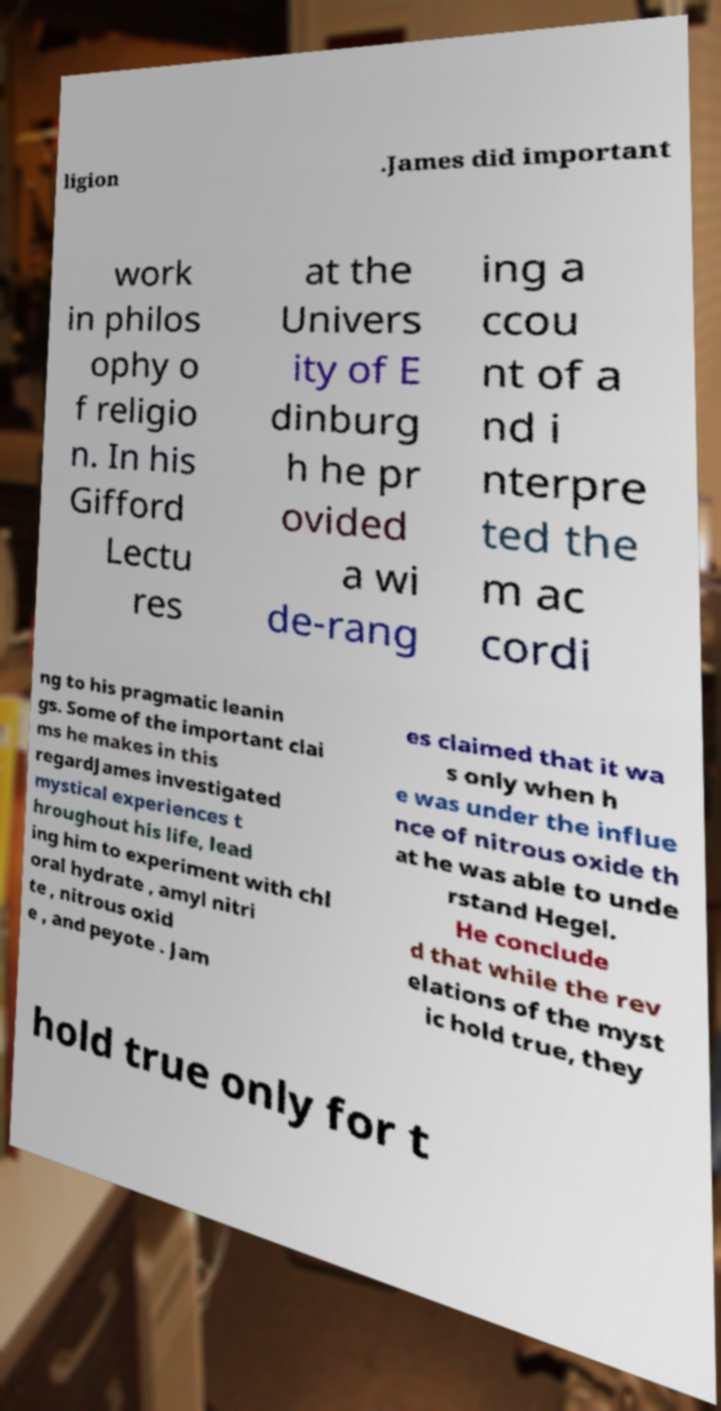Please identify and transcribe the text found in this image. ligion .James did important work in philos ophy o f religio n. In his Gifford Lectu res at the Univers ity of E dinburg h he pr ovided a wi de-rang ing a ccou nt of a nd i nterpre ted the m ac cordi ng to his pragmatic leanin gs. Some of the important clai ms he makes in this regardJames investigated mystical experiences t hroughout his life, lead ing him to experiment with chl oral hydrate , amyl nitri te , nitrous oxid e , and peyote . Jam es claimed that it wa s only when h e was under the influe nce of nitrous oxide th at he was able to unde rstand Hegel. He conclude d that while the rev elations of the myst ic hold true, they hold true only for t 